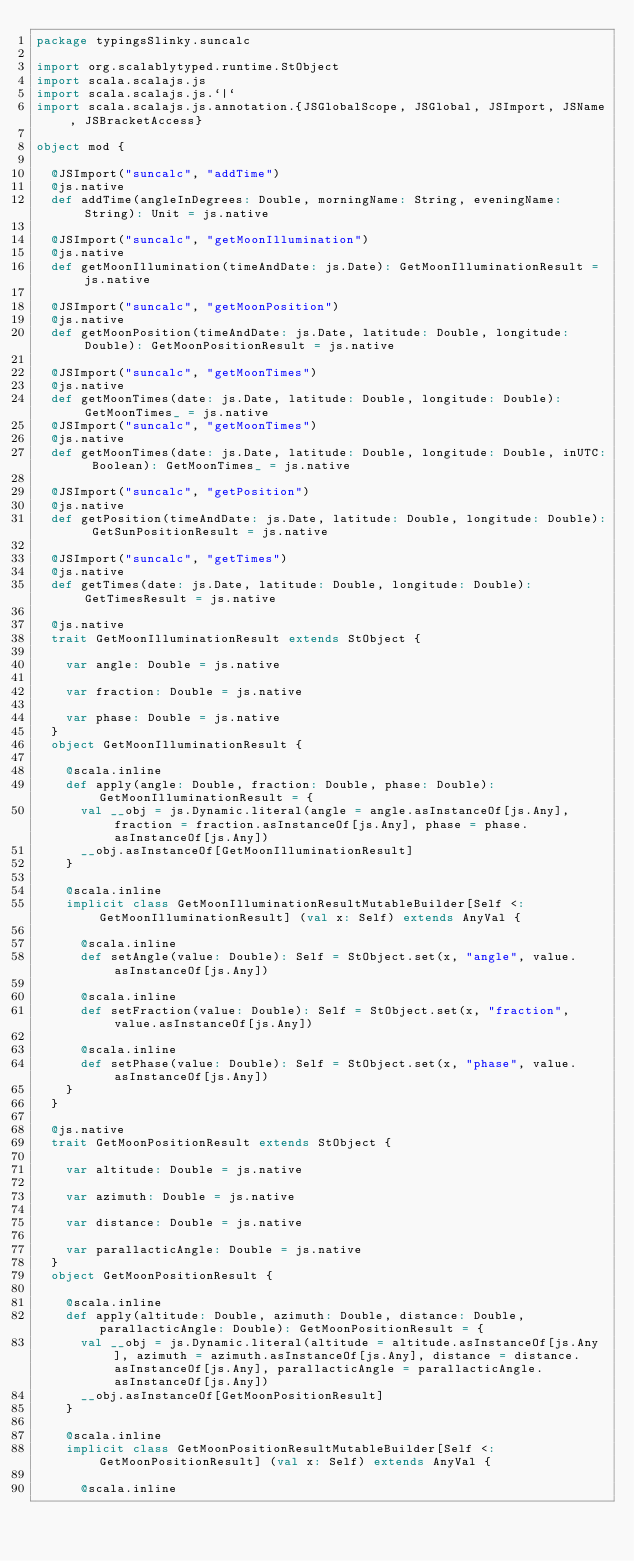<code> <loc_0><loc_0><loc_500><loc_500><_Scala_>package typingsSlinky.suncalc

import org.scalablytyped.runtime.StObject
import scala.scalajs.js
import scala.scalajs.js.`|`
import scala.scalajs.js.annotation.{JSGlobalScope, JSGlobal, JSImport, JSName, JSBracketAccess}

object mod {
  
  @JSImport("suncalc", "addTime")
  @js.native
  def addTime(angleInDegrees: Double, morningName: String, eveningName: String): Unit = js.native
  
  @JSImport("suncalc", "getMoonIllumination")
  @js.native
  def getMoonIllumination(timeAndDate: js.Date): GetMoonIlluminationResult = js.native
  
  @JSImport("suncalc", "getMoonPosition")
  @js.native
  def getMoonPosition(timeAndDate: js.Date, latitude: Double, longitude: Double): GetMoonPositionResult = js.native
  
  @JSImport("suncalc", "getMoonTimes")
  @js.native
  def getMoonTimes(date: js.Date, latitude: Double, longitude: Double): GetMoonTimes_ = js.native
  @JSImport("suncalc", "getMoonTimes")
  @js.native
  def getMoonTimes(date: js.Date, latitude: Double, longitude: Double, inUTC: Boolean): GetMoonTimes_ = js.native
  
  @JSImport("suncalc", "getPosition")
  @js.native
  def getPosition(timeAndDate: js.Date, latitude: Double, longitude: Double): GetSunPositionResult = js.native
  
  @JSImport("suncalc", "getTimes")
  @js.native
  def getTimes(date: js.Date, latitude: Double, longitude: Double): GetTimesResult = js.native
  
  @js.native
  trait GetMoonIlluminationResult extends StObject {
    
    var angle: Double = js.native
    
    var fraction: Double = js.native
    
    var phase: Double = js.native
  }
  object GetMoonIlluminationResult {
    
    @scala.inline
    def apply(angle: Double, fraction: Double, phase: Double): GetMoonIlluminationResult = {
      val __obj = js.Dynamic.literal(angle = angle.asInstanceOf[js.Any], fraction = fraction.asInstanceOf[js.Any], phase = phase.asInstanceOf[js.Any])
      __obj.asInstanceOf[GetMoonIlluminationResult]
    }
    
    @scala.inline
    implicit class GetMoonIlluminationResultMutableBuilder[Self <: GetMoonIlluminationResult] (val x: Self) extends AnyVal {
      
      @scala.inline
      def setAngle(value: Double): Self = StObject.set(x, "angle", value.asInstanceOf[js.Any])
      
      @scala.inline
      def setFraction(value: Double): Self = StObject.set(x, "fraction", value.asInstanceOf[js.Any])
      
      @scala.inline
      def setPhase(value: Double): Self = StObject.set(x, "phase", value.asInstanceOf[js.Any])
    }
  }
  
  @js.native
  trait GetMoonPositionResult extends StObject {
    
    var altitude: Double = js.native
    
    var azimuth: Double = js.native
    
    var distance: Double = js.native
    
    var parallacticAngle: Double = js.native
  }
  object GetMoonPositionResult {
    
    @scala.inline
    def apply(altitude: Double, azimuth: Double, distance: Double, parallacticAngle: Double): GetMoonPositionResult = {
      val __obj = js.Dynamic.literal(altitude = altitude.asInstanceOf[js.Any], azimuth = azimuth.asInstanceOf[js.Any], distance = distance.asInstanceOf[js.Any], parallacticAngle = parallacticAngle.asInstanceOf[js.Any])
      __obj.asInstanceOf[GetMoonPositionResult]
    }
    
    @scala.inline
    implicit class GetMoonPositionResultMutableBuilder[Self <: GetMoonPositionResult] (val x: Self) extends AnyVal {
      
      @scala.inline</code> 